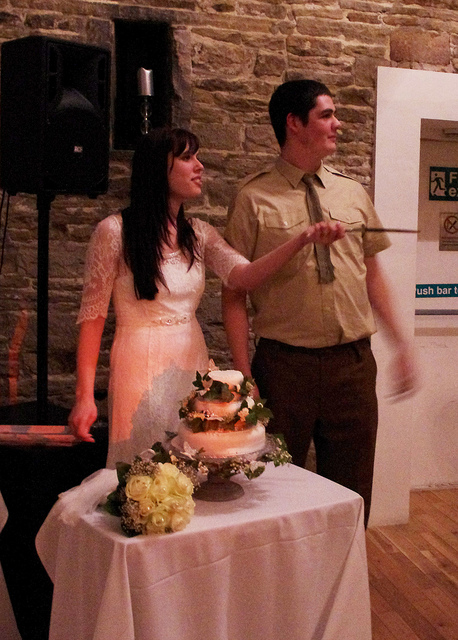<image>What design is on the skirt? It's unknown what design is on the skirt. It can be ruffles, solid, lace or none. What flavor is the cake? I don't know the flavor of the cake. It is possibly vanilla. What design is on the skirt? It can be seen different design on the skirt such as 'ruffles', 'solid', 'lace', 'plain', 'solid white', and 'solid color'. What flavor is the cake? I don't know what flavor the cake is. But it is most likely vanilla. 